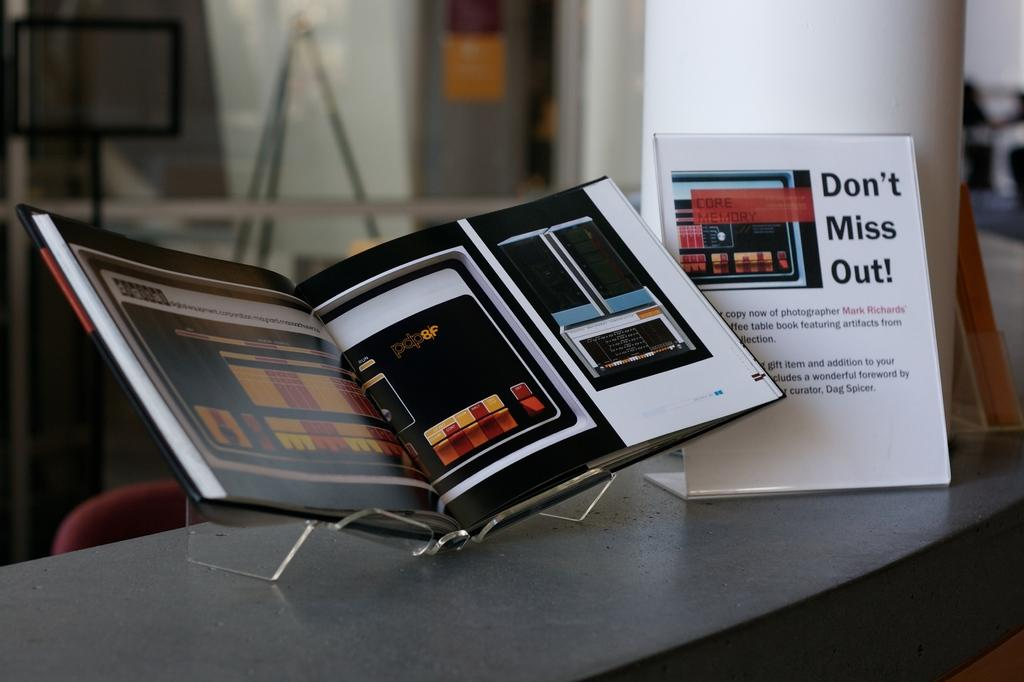<image>
Share a concise interpretation of the image provided. An open book next to a flyer that says Don't Miss Out! 